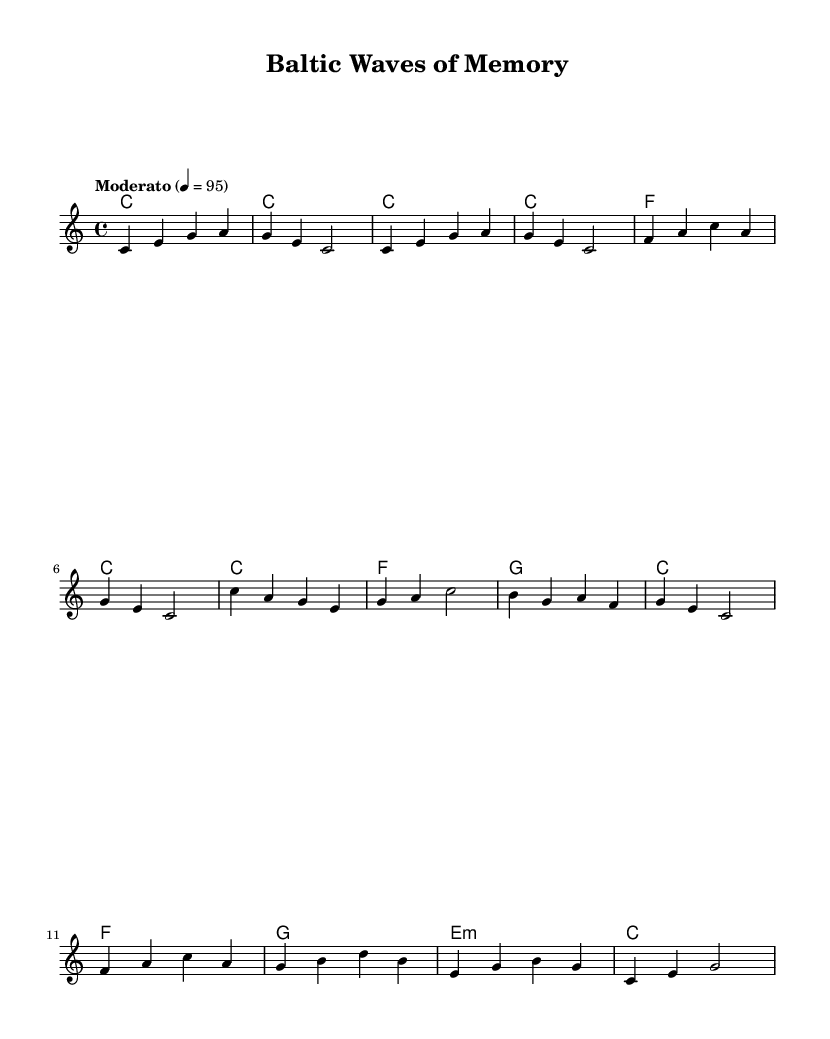What is the key signature of this music? The key signature can be determined by looking for sharps or flats in the clef area at the beginning of the score. Since there are none, the key signature is C major, which has no sharps or flats.
Answer: C major What is the time signature of this music? The time signature can be found in the fraction format at the beginning of the score. Here, it is indicated as 4/4, which means there are four beats in a measure and a quarter note receives one beat.
Answer: 4/4 What is the tempo indication? The tempo indication is found in the markings above the staff. It is labeled as "Moderato" with a specific beat of 95, indicating a moderate pace.
Answer: Moderato How many measures are in the Chorus section? By examining the score, the Chorus section is represented by the notes between the correlating chord indicators. Counting these measures, there are four distinct measures in the Chorus.
Answer: 4 What is the harmonic structure during the Bridge? The Bridge is analyzed by looking at the harmonies corresponding to the notes in that section. In the Bridge, the harmonies are F, G, E min, and C, giving it a distinct sound characterized by these chords.
Answer: F, G, E min, C What is the first note of the melody? The first note of the melody can be identified by looking at the first note in the melody staff. The note is C, which is located on a space before the first line of the staff.
Answer: C What type of musical style does this piece represent? The composition style can be inferred from the title and its characteristics, which suggest a nostalgic tone and soul influences, typical of the soul music genre.
Answer: Soul 